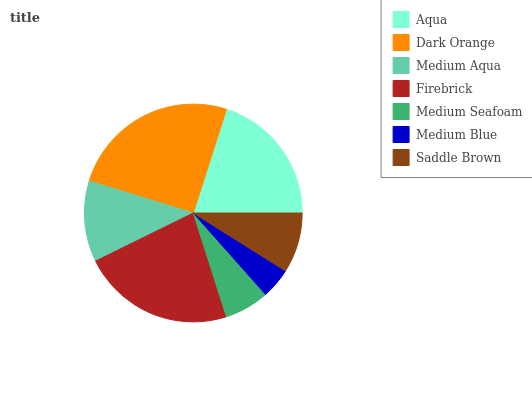Is Medium Blue the minimum?
Answer yes or no. Yes. Is Dark Orange the maximum?
Answer yes or no. Yes. Is Medium Aqua the minimum?
Answer yes or no. No. Is Medium Aqua the maximum?
Answer yes or no. No. Is Dark Orange greater than Medium Aqua?
Answer yes or no. Yes. Is Medium Aqua less than Dark Orange?
Answer yes or no. Yes. Is Medium Aqua greater than Dark Orange?
Answer yes or no. No. Is Dark Orange less than Medium Aqua?
Answer yes or no. No. Is Medium Aqua the high median?
Answer yes or no. Yes. Is Medium Aqua the low median?
Answer yes or no. Yes. Is Saddle Brown the high median?
Answer yes or no. No. Is Medium Seafoam the low median?
Answer yes or no. No. 